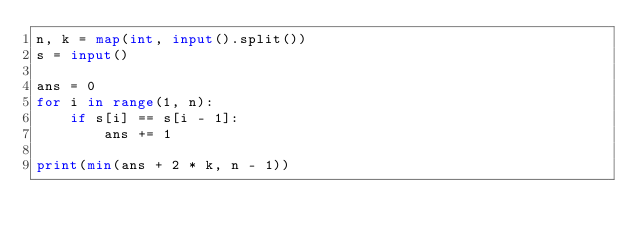Convert code to text. <code><loc_0><loc_0><loc_500><loc_500><_Python_>n, k = map(int, input().split())
s = input()

ans = 0
for i in range(1, n):
    if s[i] == s[i - 1]:
        ans += 1

print(min(ans + 2 * k, n - 1))</code> 